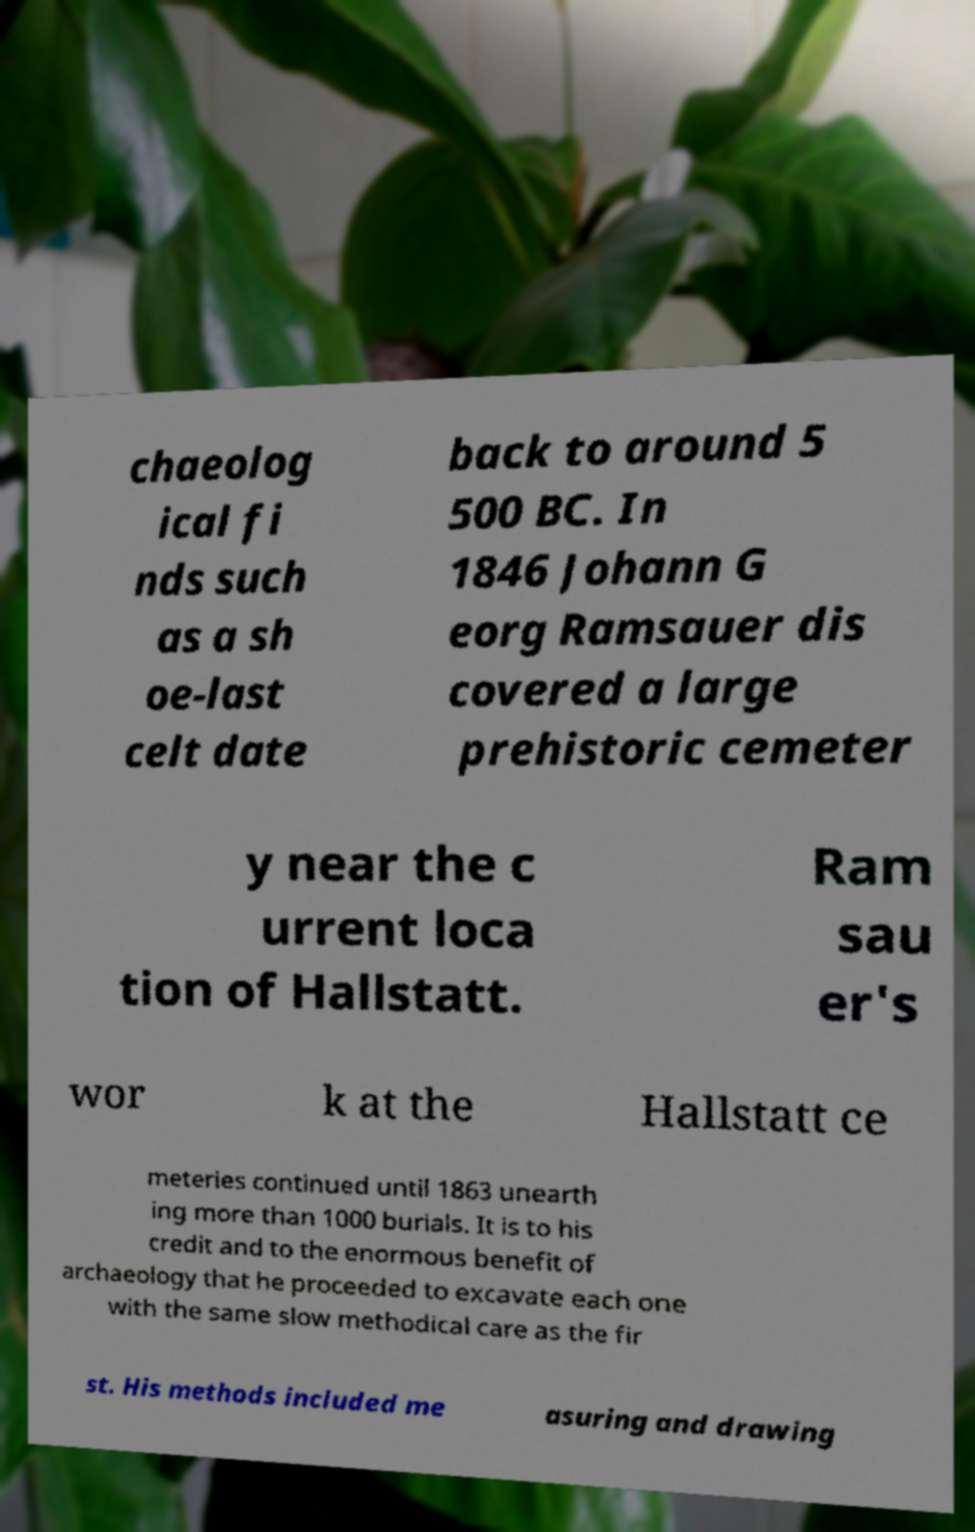I need the written content from this picture converted into text. Can you do that? chaeolog ical fi nds such as a sh oe-last celt date back to around 5 500 BC. In 1846 Johann G eorg Ramsauer dis covered a large prehistoric cemeter y near the c urrent loca tion of Hallstatt. Ram sau er's wor k at the Hallstatt ce meteries continued until 1863 unearth ing more than 1000 burials. It is to his credit and to the enormous benefit of archaeology that he proceeded to excavate each one with the same slow methodical care as the fir st. His methods included me asuring and drawing 